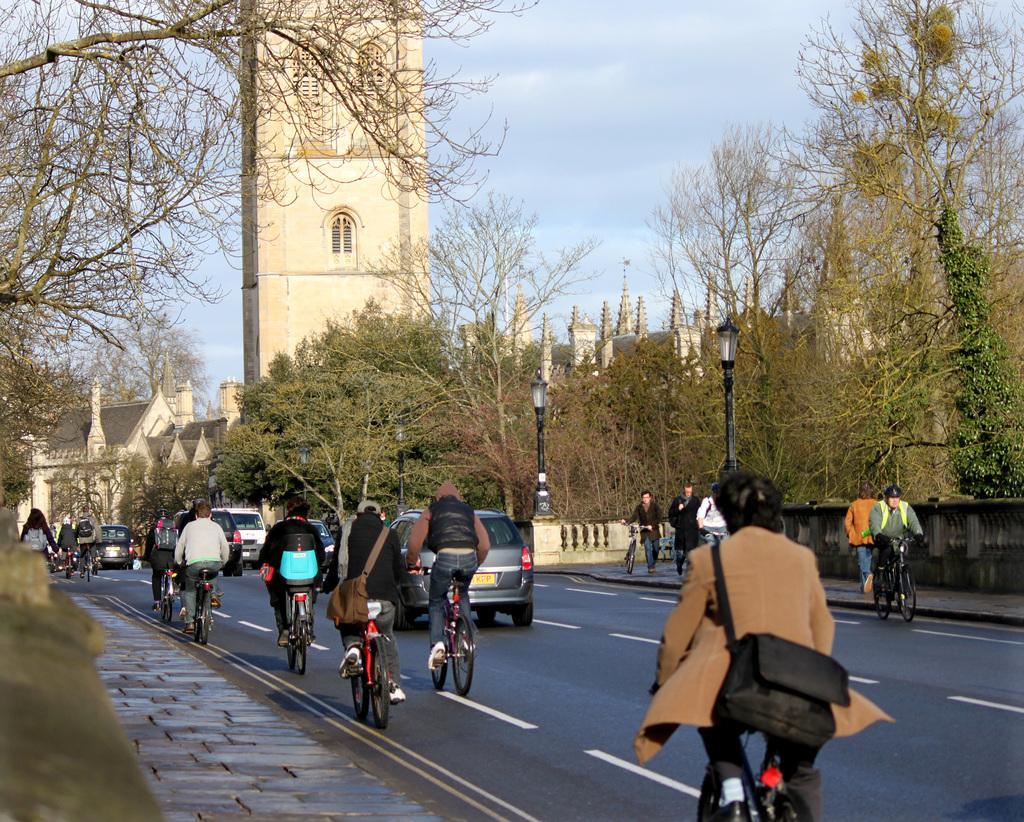Please provide a concise description of this image. In this image I can see group of people riding bicycles on the road, I can also see few vehicles, light poles, trees in green color, buildings in cream color and the sky is in white and blue color. 